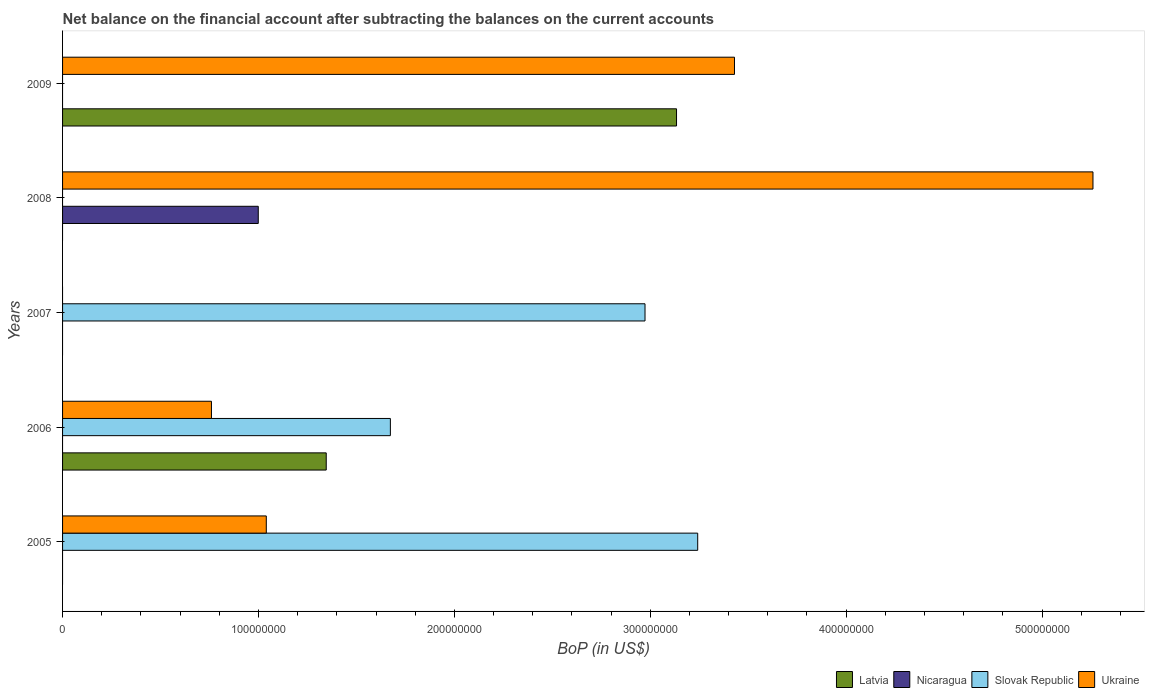How many different coloured bars are there?
Make the answer very short. 4. Are the number of bars per tick equal to the number of legend labels?
Your response must be concise. No. How many bars are there on the 5th tick from the bottom?
Provide a succinct answer. 2. In how many cases, is the number of bars for a given year not equal to the number of legend labels?
Your answer should be very brief. 5. What is the Balance of Payments in Latvia in 2006?
Give a very brief answer. 1.35e+08. Across all years, what is the maximum Balance of Payments in Slovak Republic?
Make the answer very short. 3.24e+08. What is the total Balance of Payments in Slovak Republic in the graph?
Your answer should be compact. 7.89e+08. What is the difference between the Balance of Payments in Slovak Republic in 2006 and that in 2007?
Provide a short and direct response. -1.30e+08. What is the difference between the Balance of Payments in Nicaragua in 2006 and the Balance of Payments in Ukraine in 2008?
Your answer should be very brief. -5.26e+08. What is the average Balance of Payments in Ukraine per year?
Provide a succinct answer. 2.10e+08. In the year 2006, what is the difference between the Balance of Payments in Latvia and Balance of Payments in Ukraine?
Make the answer very short. 5.86e+07. What is the ratio of the Balance of Payments in Slovak Republic in 2006 to that in 2007?
Keep it short and to the point. 0.56. What is the difference between the highest and the second highest Balance of Payments in Ukraine?
Your answer should be compact. 1.83e+08. What is the difference between the highest and the lowest Balance of Payments in Ukraine?
Ensure brevity in your answer.  5.26e+08. In how many years, is the Balance of Payments in Slovak Republic greater than the average Balance of Payments in Slovak Republic taken over all years?
Your answer should be compact. 3. Is it the case that in every year, the sum of the Balance of Payments in Slovak Republic and Balance of Payments in Latvia is greater than the sum of Balance of Payments in Nicaragua and Balance of Payments in Ukraine?
Your answer should be very brief. No. Is it the case that in every year, the sum of the Balance of Payments in Latvia and Balance of Payments in Ukraine is greater than the Balance of Payments in Nicaragua?
Your answer should be compact. No. Are all the bars in the graph horizontal?
Your answer should be compact. Yes. How many years are there in the graph?
Keep it short and to the point. 5. What is the difference between two consecutive major ticks on the X-axis?
Give a very brief answer. 1.00e+08. Does the graph contain any zero values?
Offer a very short reply. Yes. Does the graph contain grids?
Make the answer very short. No. How many legend labels are there?
Your answer should be very brief. 4. What is the title of the graph?
Keep it short and to the point. Net balance on the financial account after subtracting the balances on the current accounts. What is the label or title of the X-axis?
Offer a terse response. BoP (in US$). What is the BoP (in US$) of Nicaragua in 2005?
Your response must be concise. 0. What is the BoP (in US$) in Slovak Republic in 2005?
Provide a short and direct response. 3.24e+08. What is the BoP (in US$) of Ukraine in 2005?
Your answer should be very brief. 1.04e+08. What is the BoP (in US$) of Latvia in 2006?
Keep it short and to the point. 1.35e+08. What is the BoP (in US$) of Slovak Republic in 2006?
Keep it short and to the point. 1.67e+08. What is the BoP (in US$) of Ukraine in 2006?
Your response must be concise. 7.60e+07. What is the BoP (in US$) of Latvia in 2007?
Your response must be concise. 0. What is the BoP (in US$) in Slovak Republic in 2007?
Your answer should be very brief. 2.97e+08. What is the BoP (in US$) in Ukraine in 2007?
Provide a short and direct response. 0. What is the BoP (in US$) of Nicaragua in 2008?
Provide a short and direct response. 9.99e+07. What is the BoP (in US$) in Ukraine in 2008?
Give a very brief answer. 5.26e+08. What is the BoP (in US$) of Latvia in 2009?
Provide a short and direct response. 3.13e+08. What is the BoP (in US$) in Ukraine in 2009?
Keep it short and to the point. 3.43e+08. Across all years, what is the maximum BoP (in US$) in Latvia?
Ensure brevity in your answer.  3.13e+08. Across all years, what is the maximum BoP (in US$) in Nicaragua?
Provide a succinct answer. 9.99e+07. Across all years, what is the maximum BoP (in US$) of Slovak Republic?
Offer a very short reply. 3.24e+08. Across all years, what is the maximum BoP (in US$) in Ukraine?
Make the answer very short. 5.26e+08. Across all years, what is the minimum BoP (in US$) of Slovak Republic?
Provide a succinct answer. 0. Across all years, what is the minimum BoP (in US$) in Ukraine?
Provide a succinct answer. 0. What is the total BoP (in US$) of Latvia in the graph?
Provide a short and direct response. 4.48e+08. What is the total BoP (in US$) in Nicaragua in the graph?
Offer a terse response. 9.99e+07. What is the total BoP (in US$) of Slovak Republic in the graph?
Your answer should be very brief. 7.89e+08. What is the total BoP (in US$) in Ukraine in the graph?
Offer a terse response. 1.05e+09. What is the difference between the BoP (in US$) of Slovak Republic in 2005 and that in 2006?
Your answer should be compact. 1.57e+08. What is the difference between the BoP (in US$) in Ukraine in 2005 and that in 2006?
Ensure brevity in your answer.  2.80e+07. What is the difference between the BoP (in US$) of Slovak Republic in 2005 and that in 2007?
Keep it short and to the point. 2.69e+07. What is the difference between the BoP (in US$) in Ukraine in 2005 and that in 2008?
Your answer should be compact. -4.22e+08. What is the difference between the BoP (in US$) of Ukraine in 2005 and that in 2009?
Keep it short and to the point. -2.39e+08. What is the difference between the BoP (in US$) of Slovak Republic in 2006 and that in 2007?
Offer a very short reply. -1.30e+08. What is the difference between the BoP (in US$) in Ukraine in 2006 and that in 2008?
Your response must be concise. -4.50e+08. What is the difference between the BoP (in US$) of Latvia in 2006 and that in 2009?
Your answer should be compact. -1.79e+08. What is the difference between the BoP (in US$) in Ukraine in 2006 and that in 2009?
Provide a short and direct response. -2.67e+08. What is the difference between the BoP (in US$) of Ukraine in 2008 and that in 2009?
Make the answer very short. 1.83e+08. What is the difference between the BoP (in US$) in Slovak Republic in 2005 and the BoP (in US$) in Ukraine in 2006?
Keep it short and to the point. 2.48e+08. What is the difference between the BoP (in US$) in Slovak Republic in 2005 and the BoP (in US$) in Ukraine in 2008?
Ensure brevity in your answer.  -2.02e+08. What is the difference between the BoP (in US$) of Slovak Republic in 2005 and the BoP (in US$) of Ukraine in 2009?
Your answer should be very brief. -1.88e+07. What is the difference between the BoP (in US$) in Latvia in 2006 and the BoP (in US$) in Slovak Republic in 2007?
Ensure brevity in your answer.  -1.63e+08. What is the difference between the BoP (in US$) of Latvia in 2006 and the BoP (in US$) of Nicaragua in 2008?
Provide a succinct answer. 3.47e+07. What is the difference between the BoP (in US$) of Latvia in 2006 and the BoP (in US$) of Ukraine in 2008?
Your answer should be compact. -3.91e+08. What is the difference between the BoP (in US$) of Slovak Republic in 2006 and the BoP (in US$) of Ukraine in 2008?
Your response must be concise. -3.59e+08. What is the difference between the BoP (in US$) of Latvia in 2006 and the BoP (in US$) of Ukraine in 2009?
Ensure brevity in your answer.  -2.08e+08. What is the difference between the BoP (in US$) of Slovak Republic in 2006 and the BoP (in US$) of Ukraine in 2009?
Provide a succinct answer. -1.76e+08. What is the difference between the BoP (in US$) in Slovak Republic in 2007 and the BoP (in US$) in Ukraine in 2008?
Your answer should be compact. -2.29e+08. What is the difference between the BoP (in US$) in Slovak Republic in 2007 and the BoP (in US$) in Ukraine in 2009?
Make the answer very short. -4.57e+07. What is the difference between the BoP (in US$) of Nicaragua in 2008 and the BoP (in US$) of Ukraine in 2009?
Make the answer very short. -2.43e+08. What is the average BoP (in US$) in Latvia per year?
Provide a short and direct response. 8.96e+07. What is the average BoP (in US$) in Nicaragua per year?
Your answer should be very brief. 2.00e+07. What is the average BoP (in US$) in Slovak Republic per year?
Provide a short and direct response. 1.58e+08. What is the average BoP (in US$) in Ukraine per year?
Your answer should be compact. 2.10e+08. In the year 2005, what is the difference between the BoP (in US$) in Slovak Republic and BoP (in US$) in Ukraine?
Provide a succinct answer. 2.20e+08. In the year 2006, what is the difference between the BoP (in US$) in Latvia and BoP (in US$) in Slovak Republic?
Your answer should be very brief. -3.27e+07. In the year 2006, what is the difference between the BoP (in US$) of Latvia and BoP (in US$) of Ukraine?
Ensure brevity in your answer.  5.86e+07. In the year 2006, what is the difference between the BoP (in US$) of Slovak Republic and BoP (in US$) of Ukraine?
Your answer should be very brief. 9.13e+07. In the year 2008, what is the difference between the BoP (in US$) of Nicaragua and BoP (in US$) of Ukraine?
Provide a succinct answer. -4.26e+08. In the year 2009, what is the difference between the BoP (in US$) in Latvia and BoP (in US$) in Ukraine?
Your response must be concise. -2.96e+07. What is the ratio of the BoP (in US$) of Slovak Republic in 2005 to that in 2006?
Offer a very short reply. 1.94. What is the ratio of the BoP (in US$) of Ukraine in 2005 to that in 2006?
Your answer should be very brief. 1.37. What is the ratio of the BoP (in US$) in Slovak Republic in 2005 to that in 2007?
Make the answer very short. 1.09. What is the ratio of the BoP (in US$) of Ukraine in 2005 to that in 2008?
Ensure brevity in your answer.  0.2. What is the ratio of the BoP (in US$) of Ukraine in 2005 to that in 2009?
Make the answer very short. 0.3. What is the ratio of the BoP (in US$) in Slovak Republic in 2006 to that in 2007?
Offer a terse response. 0.56. What is the ratio of the BoP (in US$) in Ukraine in 2006 to that in 2008?
Your answer should be compact. 0.14. What is the ratio of the BoP (in US$) in Latvia in 2006 to that in 2009?
Offer a terse response. 0.43. What is the ratio of the BoP (in US$) of Ukraine in 2006 to that in 2009?
Make the answer very short. 0.22. What is the ratio of the BoP (in US$) in Ukraine in 2008 to that in 2009?
Provide a succinct answer. 1.53. What is the difference between the highest and the second highest BoP (in US$) of Slovak Republic?
Provide a short and direct response. 2.69e+07. What is the difference between the highest and the second highest BoP (in US$) of Ukraine?
Your answer should be very brief. 1.83e+08. What is the difference between the highest and the lowest BoP (in US$) of Latvia?
Offer a terse response. 3.13e+08. What is the difference between the highest and the lowest BoP (in US$) in Nicaragua?
Provide a succinct answer. 9.99e+07. What is the difference between the highest and the lowest BoP (in US$) of Slovak Republic?
Your response must be concise. 3.24e+08. What is the difference between the highest and the lowest BoP (in US$) of Ukraine?
Offer a very short reply. 5.26e+08. 